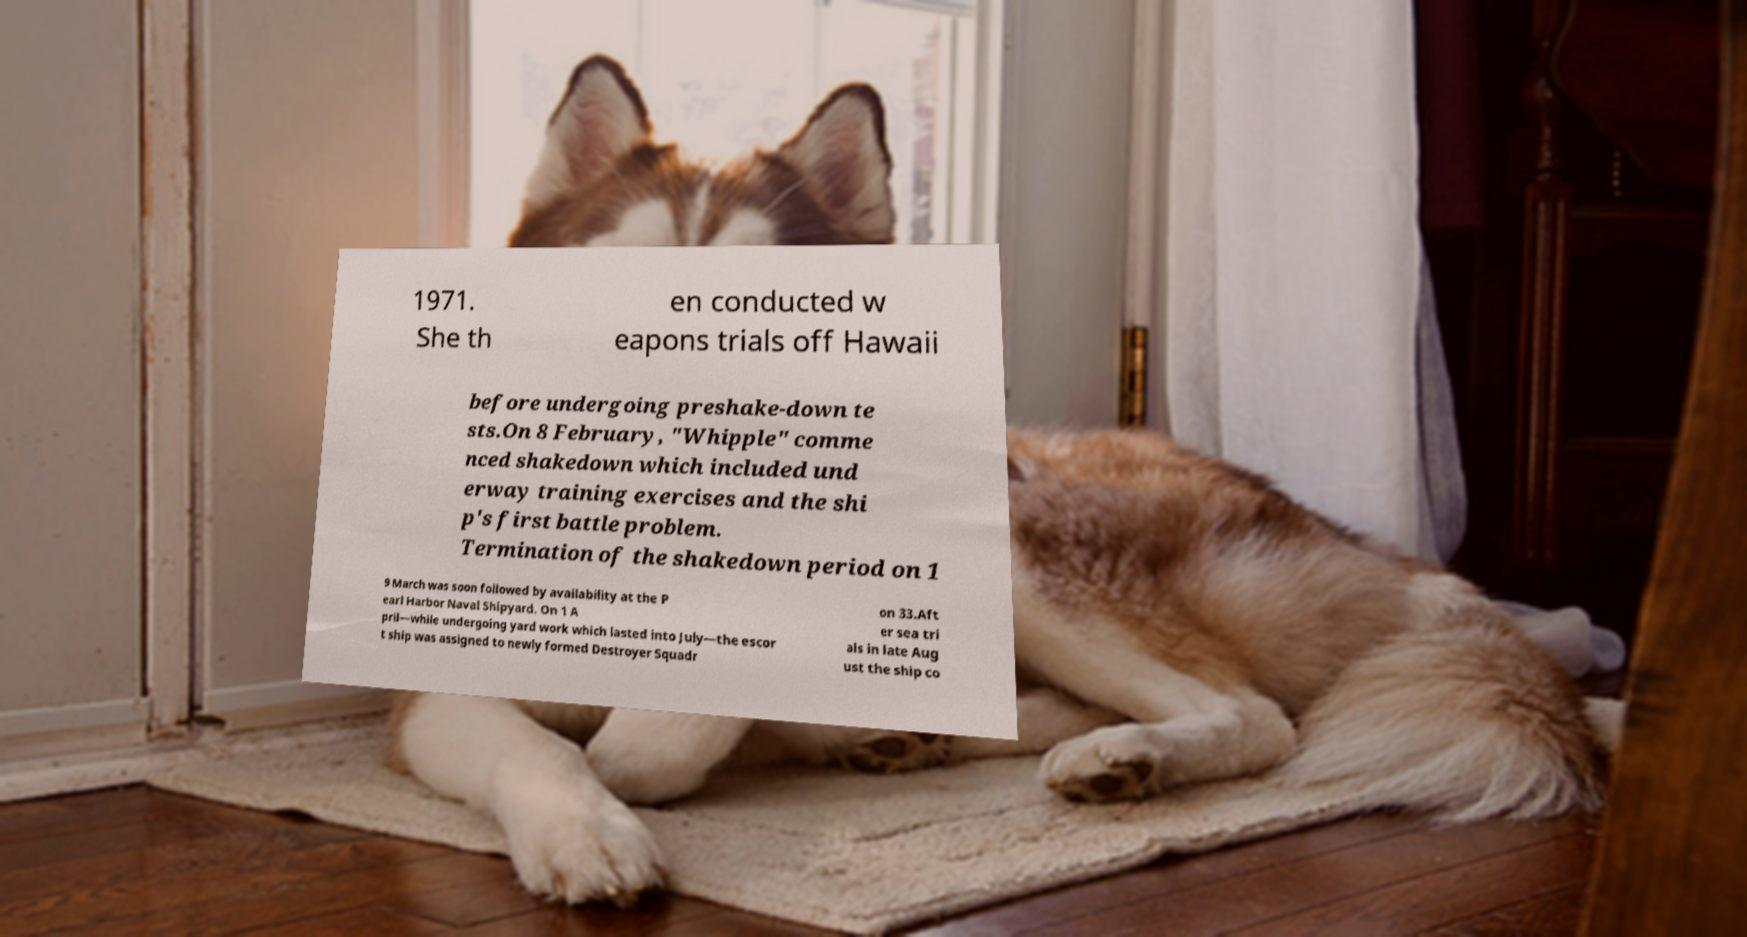What messages or text are displayed in this image? I need them in a readable, typed format. 1971. She th en conducted w eapons trials off Hawaii before undergoing preshake-down te sts.On 8 February, "Whipple" comme nced shakedown which included und erway training exercises and the shi p's first battle problem. Termination of the shakedown period on 1 9 March was soon followed by availability at the P earl Harbor Naval Shipyard. On 1 A pril—while undergoing yard work which lasted into July—the escor t ship was assigned to newly formed Destroyer Squadr on 33.Aft er sea tri als in late Aug ust the ship co 